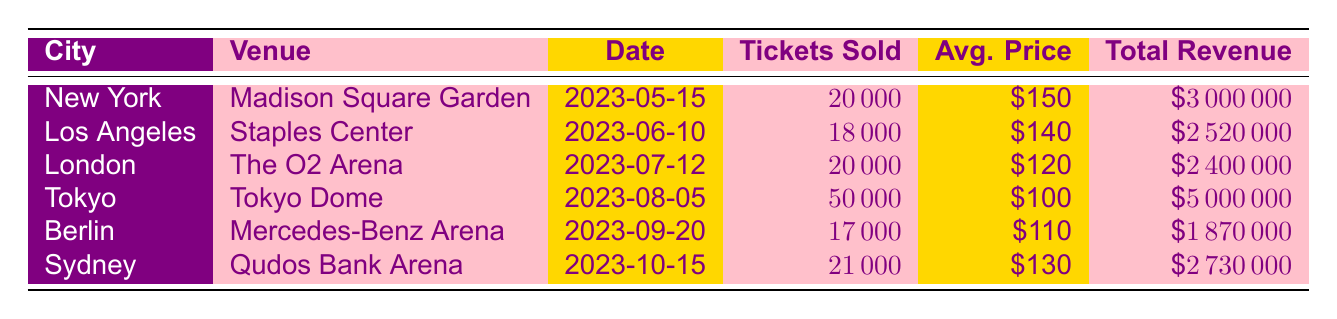What was the total revenue generated from the concert in New York? The total revenue for the New York concert, held at Madison Square Garden, is listed in the table as $3,000,000.
Answer: $3,000,000 Which concert had the highest average ticket price? In the table, the average ticket prices are $150 for New York, $140 for Los Angeles, $120 for London, $100 for Tokyo, $110 for Berlin, and $130 for Sydney. The highest among these is $150 for New York.
Answer: New York How many tickets were sold in total for all concerts? To find the total tickets sold, we sum the tickets sold for each concert: 20000 (New York) + 18000 (Los Angeles) + 20000 (London) + 50000 (Tokyo) + 17000 (Berlin) + 21000 (Sydney) = 116000 tickets.
Answer: 116,000 Did the Sydney concert generate more revenue than the Berlin concert? The total revenue for the Sydney concert is $2,730,000, while the Berlin concert generated $1,870,000. Since $2,730,000 is greater than $1,870,000, the statement is true.
Answer: Yes What is the average number of tickets sold across all concerts? To calculate the average, first sum all tickets sold: 20000 + 18000 + 20000 + 50000 + 17000 + 21000 = 116000. Then, divide by the number of concerts (6): 116000 / 6 = 19333.33. Thus, the average number of tickets sold is approximately 19333.
Answer: 19,333 Which city had the lowest total revenue? By comparing the total revenue from each city, we see New York: $3,000,000, Los Angeles: $2,520,000, London: $2,400,000, Tokyo: $5,000,000, Berlin: $1,870,000, and Sydney: $2,730,000. The lowest total revenue is from Berlin at $1,870,000.
Answer: Berlin How many more tickets were sold in Tokyo than in Los Angeles? The table shows that Tokyo sold 50,000 tickets and Los Angeles sold 18,000 tickets. Subtracting the two gives us 50,000 - 18,000 = 32,000 tickets more sold in Tokyo.
Answer: 32,000 Is the average ticket price for the concert in Tokyo higher than in London? The average ticket price for Tokyo is $100, while London's average ticket price is $120. Therefore, $100 is not greater than $120, making the statement false.
Answer: No 